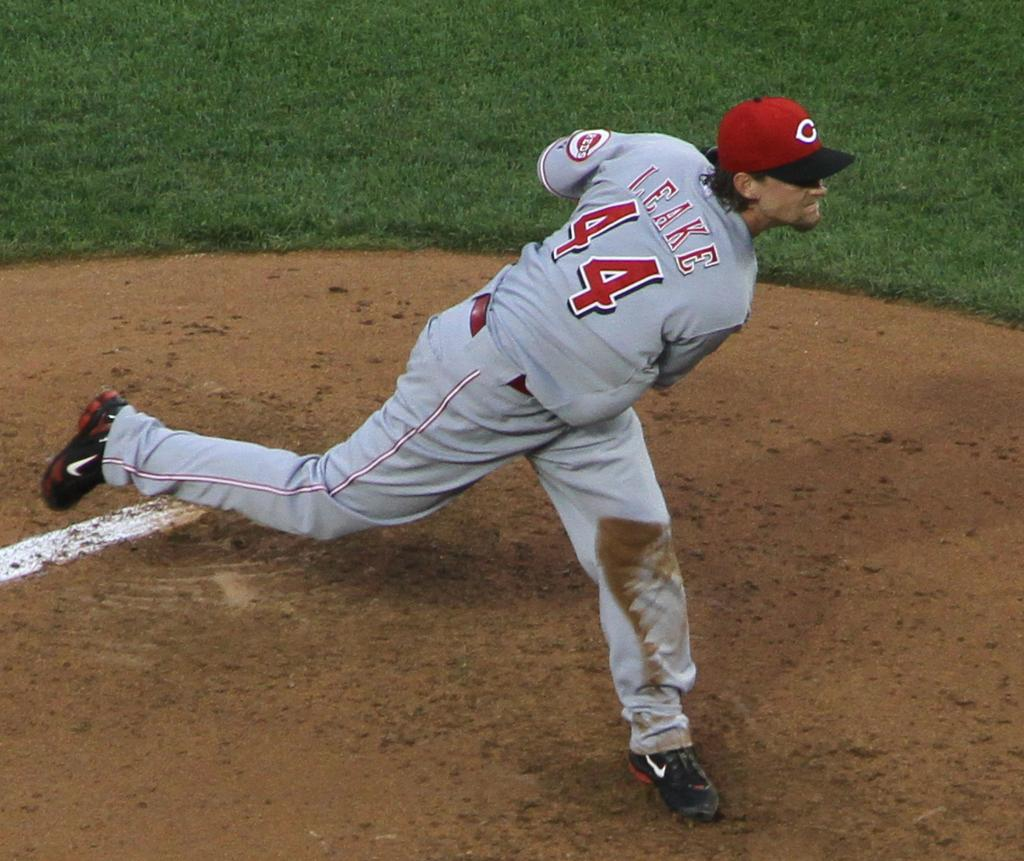<image>
Share a concise interpretation of the image provided. Leake #44 has just thrown the ball in this picture. 